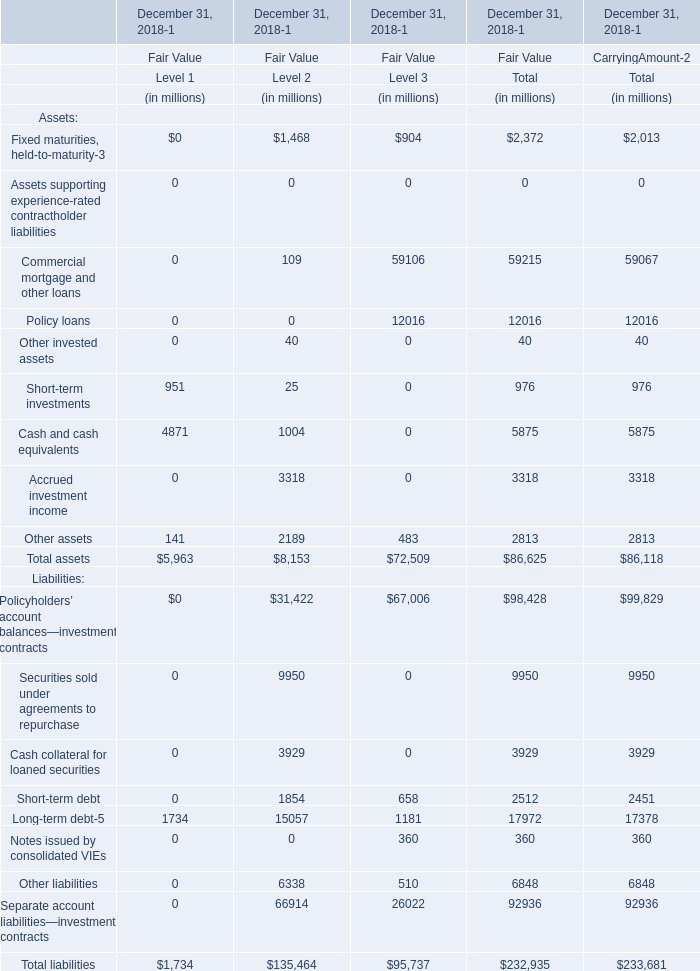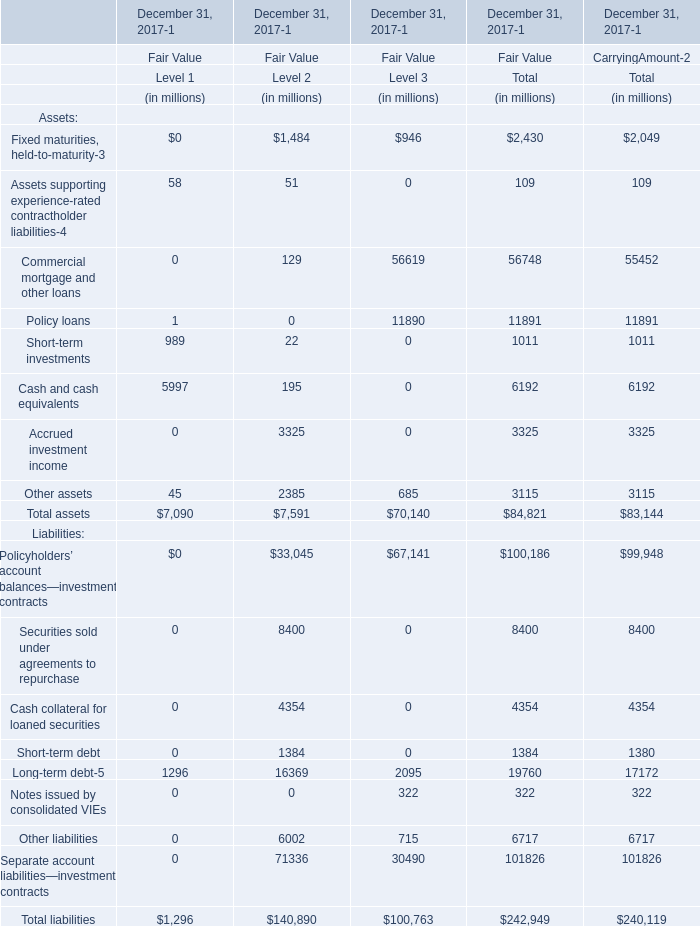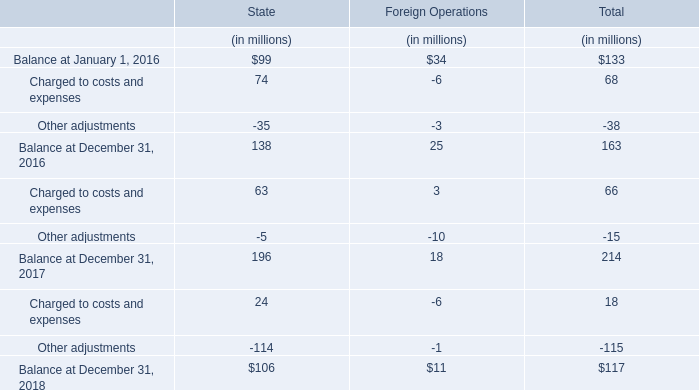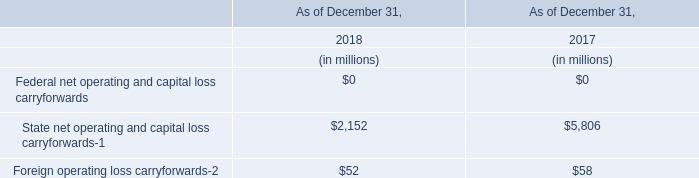What was the total amount of Level 1 greater than 0 in 2018 ? (in million) 
Computations: (((951 + 4871) + 1734) + 141)
Answer: 7697.0. 